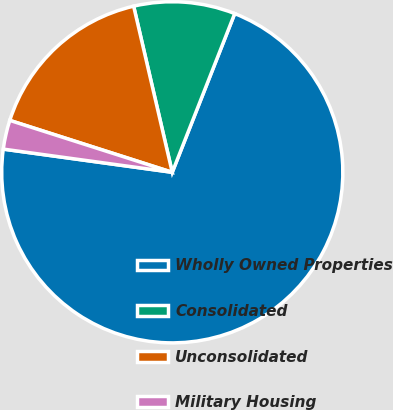<chart> <loc_0><loc_0><loc_500><loc_500><pie_chart><fcel>Wholly Owned Properties<fcel>Consolidated<fcel>Unconsolidated<fcel>Military Housing<nl><fcel>71.2%<fcel>9.6%<fcel>16.44%<fcel>2.75%<nl></chart> 